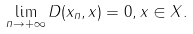<formula> <loc_0><loc_0><loc_500><loc_500>\lim _ { n \to + \infty } D ( x _ { n } , x ) = 0 , x \in X .</formula> 